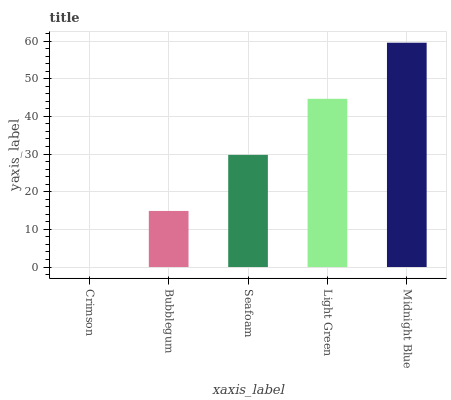Is Crimson the minimum?
Answer yes or no. Yes. Is Midnight Blue the maximum?
Answer yes or no. Yes. Is Bubblegum the minimum?
Answer yes or no. No. Is Bubblegum the maximum?
Answer yes or no. No. Is Bubblegum greater than Crimson?
Answer yes or no. Yes. Is Crimson less than Bubblegum?
Answer yes or no. Yes. Is Crimson greater than Bubblegum?
Answer yes or no. No. Is Bubblegum less than Crimson?
Answer yes or no. No. Is Seafoam the high median?
Answer yes or no. Yes. Is Seafoam the low median?
Answer yes or no. Yes. Is Crimson the high median?
Answer yes or no. No. Is Bubblegum the low median?
Answer yes or no. No. 